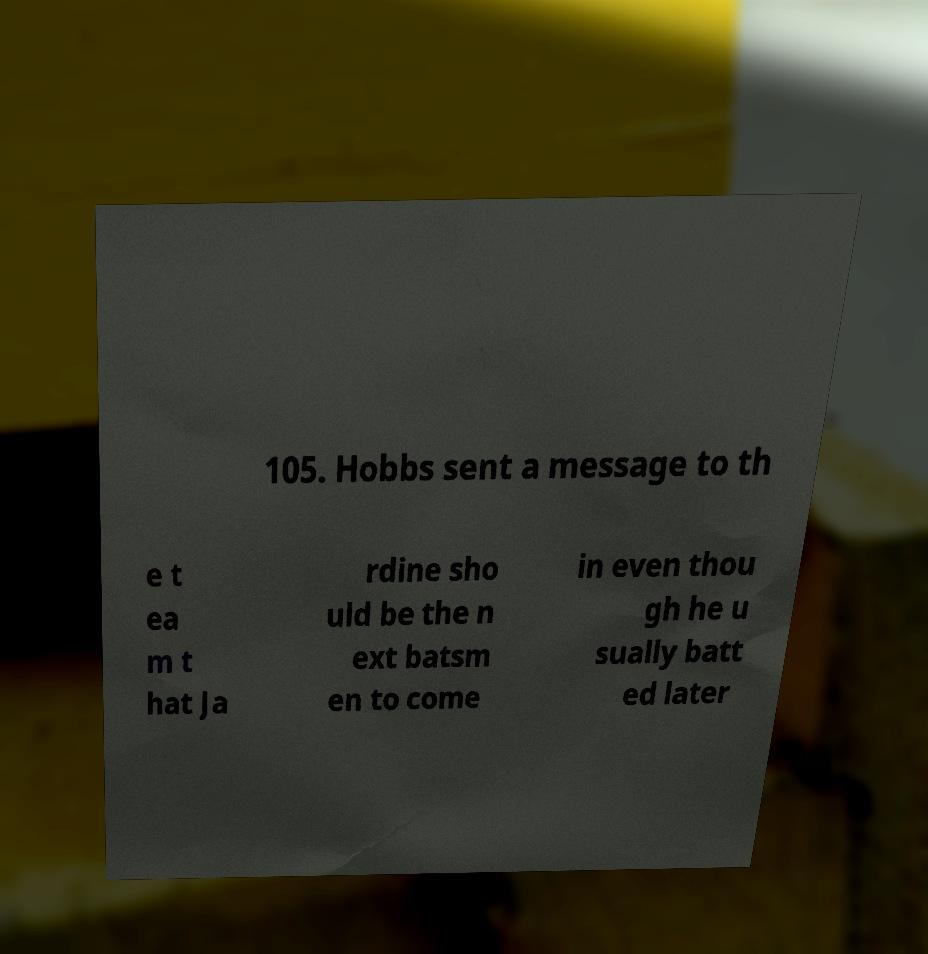Please read and relay the text visible in this image. What does it say? 105. Hobbs sent a message to th e t ea m t hat Ja rdine sho uld be the n ext batsm en to come in even thou gh he u sually batt ed later 